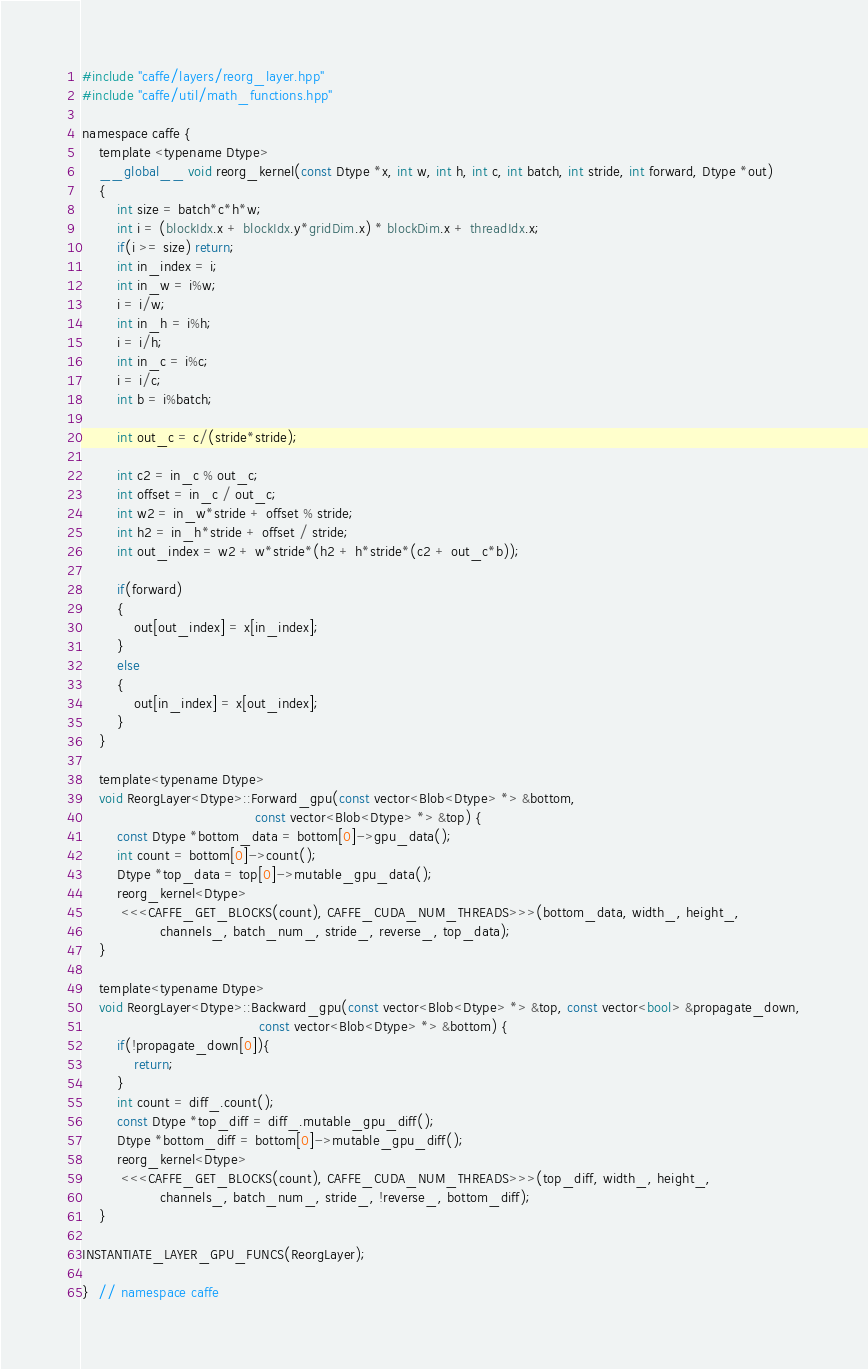Convert code to text. <code><loc_0><loc_0><loc_500><loc_500><_Cuda_>#include "caffe/layers/reorg_layer.hpp"
#include "caffe/util/math_functions.hpp"

namespace caffe {
    template <typename Dtype>
    __global__ void reorg_kernel(const Dtype *x, int w, int h, int c, int batch, int stride, int forward, Dtype *out)
    {
        int size = batch*c*h*w;
        int i = (blockIdx.x + blockIdx.y*gridDim.x) * blockDim.x + threadIdx.x;
        if(i >= size) return;
        int in_index = i;
        int in_w = i%w;
        i = i/w;
        int in_h = i%h;
        i = i/h;
        int in_c = i%c;
        i = i/c;
        int b = i%batch;

        int out_c = c/(stride*stride);

        int c2 = in_c % out_c;
        int offset = in_c / out_c;
        int w2 = in_w*stride + offset % stride;
        int h2 = in_h*stride + offset / stride;
        int out_index = w2 + w*stride*(h2 + h*stride*(c2 + out_c*b));

        if(forward)
        {
            out[out_index] = x[in_index];
        }         
        else
        {
            out[in_index] = x[out_index];
        }
    }

    template<typename Dtype>
    void ReorgLayer<Dtype>::Forward_gpu(const vector<Blob<Dtype> *> &bottom,
                                        const vector<Blob<Dtype> *> &top) {
        const Dtype *bottom_data = bottom[0]->gpu_data();
        int count = bottom[0]->count();
        Dtype *top_data = top[0]->mutable_gpu_data();
        reorg_kernel<Dtype>
         <<<CAFFE_GET_BLOCKS(count), CAFFE_CUDA_NUM_THREADS>>>(bottom_data, width_, height_,
                  channels_, batch_num_, stride_, reverse_, top_data);
    }

    template<typename Dtype>
    void ReorgLayer<Dtype>::Backward_gpu(const vector<Blob<Dtype> *> &top, const vector<bool> &propagate_down,
                                         const vector<Blob<Dtype> *> &bottom) {
        if(!propagate_down[0]){
            return;
        }
        int count = diff_.count();
        const Dtype *top_diff = diff_.mutable_gpu_diff();
        Dtype *bottom_diff = bottom[0]->mutable_gpu_diff();
        reorg_kernel<Dtype>
         <<<CAFFE_GET_BLOCKS(count), CAFFE_CUDA_NUM_THREADS>>>(top_diff, width_, height_,
                  channels_, batch_num_, stride_, !reverse_, bottom_diff);
    }

INSTANTIATE_LAYER_GPU_FUNCS(ReorgLayer);

}  // namespace caffe
</code> 